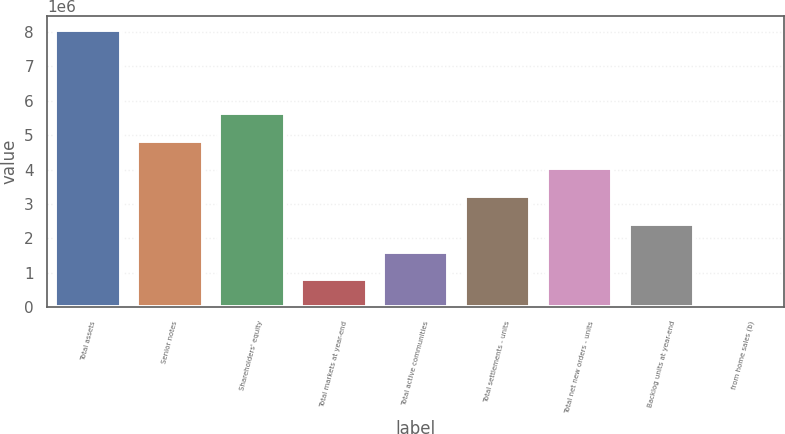Convert chart. <chart><loc_0><loc_0><loc_500><loc_500><bar_chart><fcel>Total assets<fcel>Senior notes<fcel>Shareholders' equity<fcel>Total markets at year-end<fcel>Total active communities<fcel>Total settlements - units<fcel>Total net new orders - units<fcel>Backlog units at year-end<fcel>from home sales (b)<nl><fcel>8.07215e+06<fcel>4.8433e+06<fcel>5.65051e+06<fcel>807234<fcel>1.61445e+06<fcel>3.22887e+06<fcel>4.03609e+06<fcel>2.42166e+06<fcel>20.6<nl></chart> 